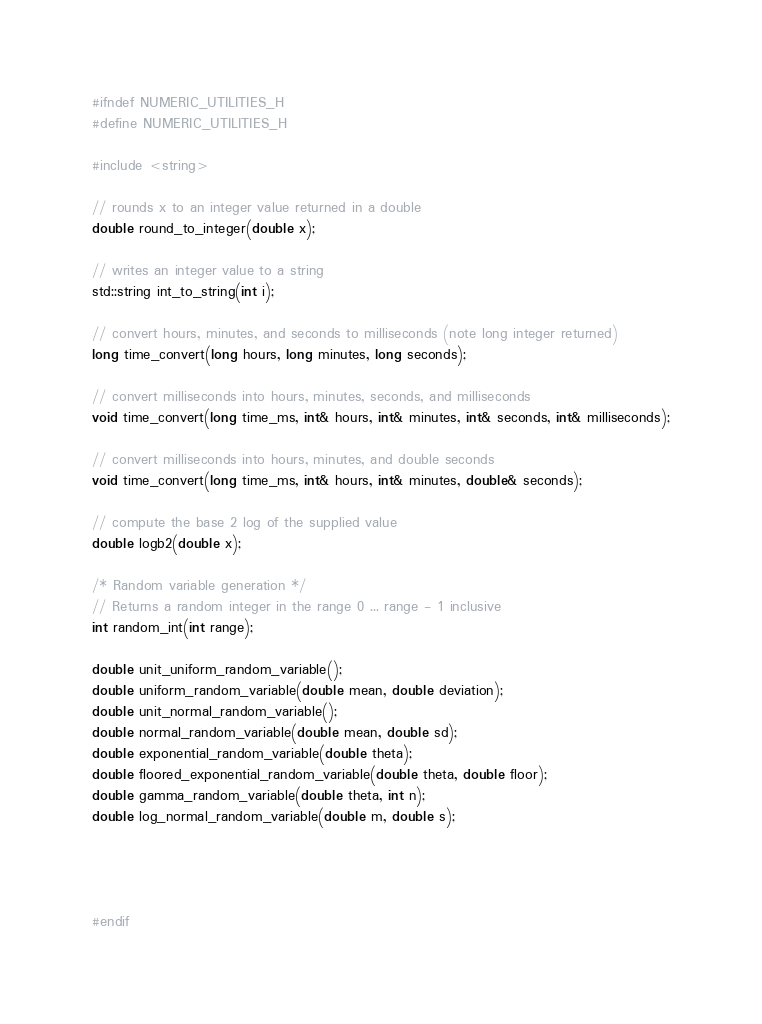Convert code to text. <code><loc_0><loc_0><loc_500><loc_500><_C_>#ifndef NUMERIC_UTILITIES_H
#define NUMERIC_UTILITIES_H

#include <string>

// rounds x to an integer value returned in a double
double round_to_integer(double x);

// writes an integer value to a string
std::string int_to_string(int i);

// convert hours, minutes, and seconds to milliseconds (note long integer returned)
long time_convert(long hours, long minutes, long seconds);

// convert milliseconds into hours, minutes, seconds, and milliseconds
void time_convert(long time_ms, int& hours, int& minutes, int& seconds, int& milliseconds);

// convert milliseconds into hours, minutes, and double seconds
void time_convert(long time_ms, int& hours, int& minutes, double& seconds);

// compute the base 2 log of the supplied value
double logb2(double x);

/* Random variable generation */
// Returns a random integer in the range 0 ... range - 1 inclusive
int random_int(int range);

double unit_uniform_random_variable();
double uniform_random_variable(double mean, double deviation);
double unit_normal_random_variable();
double normal_random_variable(double mean, double sd);
double exponential_random_variable(double theta);
double floored_exponential_random_variable(double theta, double floor);
double gamma_random_variable(double theta, int n);
double log_normal_random_variable(double m, double s);




#endif
</code> 